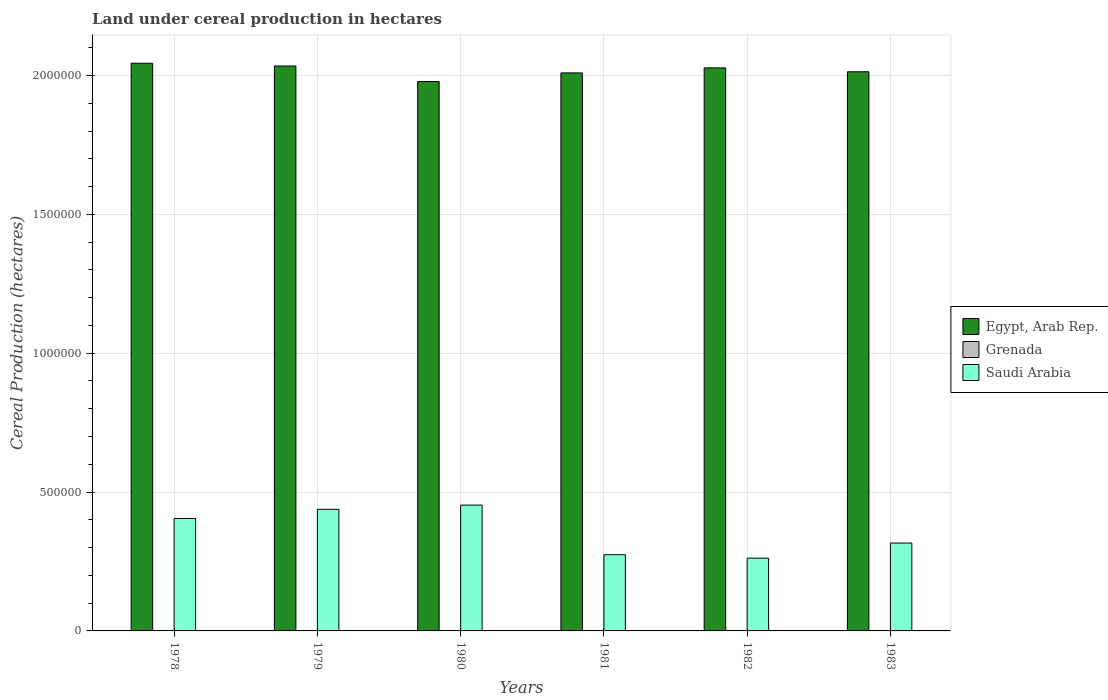How many different coloured bars are there?
Your answer should be very brief. 3. How many groups of bars are there?
Offer a very short reply. 6. Are the number of bars per tick equal to the number of legend labels?
Provide a succinct answer. Yes. Are the number of bars on each tick of the X-axis equal?
Make the answer very short. Yes. How many bars are there on the 1st tick from the right?
Your answer should be very brief. 3. What is the label of the 3rd group of bars from the left?
Offer a terse response. 1980. In how many cases, is the number of bars for a given year not equal to the number of legend labels?
Make the answer very short. 0. What is the land under cereal production in Grenada in 1981?
Your answer should be compact. 450. Across all years, what is the maximum land under cereal production in Saudi Arabia?
Your answer should be very brief. 4.53e+05. Across all years, what is the minimum land under cereal production in Egypt, Arab Rep.?
Offer a terse response. 1.98e+06. In which year was the land under cereal production in Egypt, Arab Rep. maximum?
Offer a very short reply. 1978. What is the total land under cereal production in Egypt, Arab Rep. in the graph?
Offer a terse response. 1.21e+07. What is the difference between the land under cereal production in Saudi Arabia in 1978 and that in 1980?
Ensure brevity in your answer.  -4.81e+04. What is the difference between the land under cereal production in Egypt, Arab Rep. in 1983 and the land under cereal production in Grenada in 1979?
Make the answer very short. 2.01e+06. What is the average land under cereal production in Egypt, Arab Rep. per year?
Give a very brief answer. 2.02e+06. In the year 1983, what is the difference between the land under cereal production in Grenada and land under cereal production in Saudi Arabia?
Provide a succinct answer. -3.16e+05. What is the ratio of the land under cereal production in Saudi Arabia in 1981 to that in 1983?
Provide a short and direct response. 0.87. What is the difference between the highest and the second highest land under cereal production in Grenada?
Offer a terse response. 124. What is the difference between the highest and the lowest land under cereal production in Grenada?
Offer a very short reply. 316. Is the sum of the land under cereal production in Grenada in 1979 and 1981 greater than the maximum land under cereal production in Saudi Arabia across all years?
Keep it short and to the point. No. What does the 2nd bar from the left in 1979 represents?
Ensure brevity in your answer.  Grenada. What does the 2nd bar from the right in 1981 represents?
Give a very brief answer. Grenada. Is it the case that in every year, the sum of the land under cereal production in Saudi Arabia and land under cereal production in Egypt, Arab Rep. is greater than the land under cereal production in Grenada?
Keep it short and to the point. Yes. How many bars are there?
Offer a very short reply. 18. Are all the bars in the graph horizontal?
Provide a succinct answer. No. Where does the legend appear in the graph?
Your response must be concise. Center right. How many legend labels are there?
Provide a short and direct response. 3. What is the title of the graph?
Offer a terse response. Land under cereal production in hectares. What is the label or title of the X-axis?
Your answer should be very brief. Years. What is the label or title of the Y-axis?
Ensure brevity in your answer.  Cereal Production (hectares). What is the Cereal Production (hectares) in Egypt, Arab Rep. in 1978?
Provide a succinct answer. 2.04e+06. What is the Cereal Production (hectares) of Grenada in 1978?
Offer a terse response. 730. What is the Cereal Production (hectares) in Saudi Arabia in 1978?
Keep it short and to the point. 4.05e+05. What is the Cereal Production (hectares) of Egypt, Arab Rep. in 1979?
Give a very brief answer. 2.03e+06. What is the Cereal Production (hectares) of Grenada in 1979?
Your response must be concise. 606. What is the Cereal Production (hectares) of Saudi Arabia in 1979?
Ensure brevity in your answer.  4.38e+05. What is the Cereal Production (hectares) in Egypt, Arab Rep. in 1980?
Give a very brief answer. 1.98e+06. What is the Cereal Production (hectares) in Saudi Arabia in 1980?
Make the answer very short. 4.53e+05. What is the Cereal Production (hectares) in Egypt, Arab Rep. in 1981?
Offer a very short reply. 2.01e+06. What is the Cereal Production (hectares) in Grenada in 1981?
Give a very brief answer. 450. What is the Cereal Production (hectares) of Saudi Arabia in 1981?
Make the answer very short. 2.74e+05. What is the Cereal Production (hectares) in Egypt, Arab Rep. in 1982?
Offer a very short reply. 2.03e+06. What is the Cereal Production (hectares) in Grenada in 1982?
Offer a terse response. 470. What is the Cereal Production (hectares) of Saudi Arabia in 1982?
Ensure brevity in your answer.  2.62e+05. What is the Cereal Production (hectares) of Egypt, Arab Rep. in 1983?
Provide a succinct answer. 2.01e+06. What is the Cereal Production (hectares) of Grenada in 1983?
Keep it short and to the point. 414. What is the Cereal Production (hectares) in Saudi Arabia in 1983?
Your response must be concise. 3.16e+05. Across all years, what is the maximum Cereal Production (hectares) of Egypt, Arab Rep.?
Your answer should be compact. 2.04e+06. Across all years, what is the maximum Cereal Production (hectares) of Grenada?
Offer a very short reply. 730. Across all years, what is the maximum Cereal Production (hectares) of Saudi Arabia?
Provide a succinct answer. 4.53e+05. Across all years, what is the minimum Cereal Production (hectares) in Egypt, Arab Rep.?
Ensure brevity in your answer.  1.98e+06. Across all years, what is the minimum Cereal Production (hectares) of Grenada?
Offer a terse response. 414. Across all years, what is the minimum Cereal Production (hectares) of Saudi Arabia?
Give a very brief answer. 2.62e+05. What is the total Cereal Production (hectares) of Egypt, Arab Rep. in the graph?
Keep it short and to the point. 1.21e+07. What is the total Cereal Production (hectares) in Grenada in the graph?
Offer a very short reply. 3170. What is the total Cereal Production (hectares) of Saudi Arabia in the graph?
Your answer should be compact. 2.15e+06. What is the difference between the Cereal Production (hectares) of Egypt, Arab Rep. in 1978 and that in 1979?
Your answer should be very brief. 9896. What is the difference between the Cereal Production (hectares) in Grenada in 1978 and that in 1979?
Give a very brief answer. 124. What is the difference between the Cereal Production (hectares) in Saudi Arabia in 1978 and that in 1979?
Provide a short and direct response. -3.30e+04. What is the difference between the Cereal Production (hectares) of Egypt, Arab Rep. in 1978 and that in 1980?
Ensure brevity in your answer.  6.58e+04. What is the difference between the Cereal Production (hectares) in Grenada in 1978 and that in 1980?
Ensure brevity in your answer.  230. What is the difference between the Cereal Production (hectares) in Saudi Arabia in 1978 and that in 1980?
Provide a succinct answer. -4.81e+04. What is the difference between the Cereal Production (hectares) in Egypt, Arab Rep. in 1978 and that in 1981?
Provide a succinct answer. 3.47e+04. What is the difference between the Cereal Production (hectares) of Grenada in 1978 and that in 1981?
Give a very brief answer. 280. What is the difference between the Cereal Production (hectares) of Saudi Arabia in 1978 and that in 1981?
Provide a short and direct response. 1.31e+05. What is the difference between the Cereal Production (hectares) in Egypt, Arab Rep. in 1978 and that in 1982?
Your response must be concise. 1.67e+04. What is the difference between the Cereal Production (hectares) of Grenada in 1978 and that in 1982?
Offer a terse response. 260. What is the difference between the Cereal Production (hectares) of Saudi Arabia in 1978 and that in 1982?
Keep it short and to the point. 1.43e+05. What is the difference between the Cereal Production (hectares) in Egypt, Arab Rep. in 1978 and that in 1983?
Offer a very short reply. 3.06e+04. What is the difference between the Cereal Production (hectares) of Grenada in 1978 and that in 1983?
Your response must be concise. 316. What is the difference between the Cereal Production (hectares) in Saudi Arabia in 1978 and that in 1983?
Your response must be concise. 8.85e+04. What is the difference between the Cereal Production (hectares) in Egypt, Arab Rep. in 1979 and that in 1980?
Your answer should be compact. 5.59e+04. What is the difference between the Cereal Production (hectares) in Grenada in 1979 and that in 1980?
Offer a very short reply. 106. What is the difference between the Cereal Production (hectares) of Saudi Arabia in 1979 and that in 1980?
Your answer should be very brief. -1.52e+04. What is the difference between the Cereal Production (hectares) in Egypt, Arab Rep. in 1979 and that in 1981?
Keep it short and to the point. 2.48e+04. What is the difference between the Cereal Production (hectares) in Grenada in 1979 and that in 1981?
Offer a very short reply. 156. What is the difference between the Cereal Production (hectares) of Saudi Arabia in 1979 and that in 1981?
Give a very brief answer. 1.64e+05. What is the difference between the Cereal Production (hectares) in Egypt, Arab Rep. in 1979 and that in 1982?
Provide a succinct answer. 6838. What is the difference between the Cereal Production (hectares) in Grenada in 1979 and that in 1982?
Provide a short and direct response. 136. What is the difference between the Cereal Production (hectares) of Saudi Arabia in 1979 and that in 1982?
Offer a very short reply. 1.76e+05. What is the difference between the Cereal Production (hectares) in Egypt, Arab Rep. in 1979 and that in 1983?
Your answer should be very brief. 2.07e+04. What is the difference between the Cereal Production (hectares) in Grenada in 1979 and that in 1983?
Make the answer very short. 192. What is the difference between the Cereal Production (hectares) of Saudi Arabia in 1979 and that in 1983?
Your answer should be compact. 1.21e+05. What is the difference between the Cereal Production (hectares) in Egypt, Arab Rep. in 1980 and that in 1981?
Your answer should be very brief. -3.10e+04. What is the difference between the Cereal Production (hectares) of Saudi Arabia in 1980 and that in 1981?
Your answer should be compact. 1.79e+05. What is the difference between the Cereal Production (hectares) of Egypt, Arab Rep. in 1980 and that in 1982?
Provide a short and direct response. -4.91e+04. What is the difference between the Cereal Production (hectares) in Saudi Arabia in 1980 and that in 1982?
Your response must be concise. 1.91e+05. What is the difference between the Cereal Production (hectares) of Egypt, Arab Rep. in 1980 and that in 1983?
Ensure brevity in your answer.  -3.52e+04. What is the difference between the Cereal Production (hectares) in Grenada in 1980 and that in 1983?
Provide a short and direct response. 86. What is the difference between the Cereal Production (hectares) of Saudi Arabia in 1980 and that in 1983?
Your answer should be compact. 1.37e+05. What is the difference between the Cereal Production (hectares) of Egypt, Arab Rep. in 1981 and that in 1982?
Provide a short and direct response. -1.80e+04. What is the difference between the Cereal Production (hectares) in Saudi Arabia in 1981 and that in 1982?
Offer a very short reply. 1.24e+04. What is the difference between the Cereal Production (hectares) of Egypt, Arab Rep. in 1981 and that in 1983?
Give a very brief answer. -4115. What is the difference between the Cereal Production (hectares) of Saudi Arabia in 1981 and that in 1983?
Provide a short and direct response. -4.21e+04. What is the difference between the Cereal Production (hectares) in Egypt, Arab Rep. in 1982 and that in 1983?
Provide a short and direct response. 1.39e+04. What is the difference between the Cereal Production (hectares) of Saudi Arabia in 1982 and that in 1983?
Keep it short and to the point. -5.45e+04. What is the difference between the Cereal Production (hectares) of Egypt, Arab Rep. in 1978 and the Cereal Production (hectares) of Grenada in 1979?
Your answer should be compact. 2.04e+06. What is the difference between the Cereal Production (hectares) of Egypt, Arab Rep. in 1978 and the Cereal Production (hectares) of Saudi Arabia in 1979?
Offer a terse response. 1.61e+06. What is the difference between the Cereal Production (hectares) of Grenada in 1978 and the Cereal Production (hectares) of Saudi Arabia in 1979?
Your response must be concise. -4.37e+05. What is the difference between the Cereal Production (hectares) of Egypt, Arab Rep. in 1978 and the Cereal Production (hectares) of Grenada in 1980?
Your response must be concise. 2.04e+06. What is the difference between the Cereal Production (hectares) of Egypt, Arab Rep. in 1978 and the Cereal Production (hectares) of Saudi Arabia in 1980?
Offer a terse response. 1.59e+06. What is the difference between the Cereal Production (hectares) in Grenada in 1978 and the Cereal Production (hectares) in Saudi Arabia in 1980?
Offer a terse response. -4.52e+05. What is the difference between the Cereal Production (hectares) in Egypt, Arab Rep. in 1978 and the Cereal Production (hectares) in Grenada in 1981?
Ensure brevity in your answer.  2.04e+06. What is the difference between the Cereal Production (hectares) in Egypt, Arab Rep. in 1978 and the Cereal Production (hectares) in Saudi Arabia in 1981?
Give a very brief answer. 1.77e+06. What is the difference between the Cereal Production (hectares) in Grenada in 1978 and the Cereal Production (hectares) in Saudi Arabia in 1981?
Ensure brevity in your answer.  -2.74e+05. What is the difference between the Cereal Production (hectares) in Egypt, Arab Rep. in 1978 and the Cereal Production (hectares) in Grenada in 1982?
Make the answer very short. 2.04e+06. What is the difference between the Cereal Production (hectares) in Egypt, Arab Rep. in 1978 and the Cereal Production (hectares) in Saudi Arabia in 1982?
Your response must be concise. 1.78e+06. What is the difference between the Cereal Production (hectares) in Grenada in 1978 and the Cereal Production (hectares) in Saudi Arabia in 1982?
Provide a succinct answer. -2.61e+05. What is the difference between the Cereal Production (hectares) in Egypt, Arab Rep. in 1978 and the Cereal Production (hectares) in Grenada in 1983?
Offer a very short reply. 2.04e+06. What is the difference between the Cereal Production (hectares) in Egypt, Arab Rep. in 1978 and the Cereal Production (hectares) in Saudi Arabia in 1983?
Keep it short and to the point. 1.73e+06. What is the difference between the Cereal Production (hectares) in Grenada in 1978 and the Cereal Production (hectares) in Saudi Arabia in 1983?
Your response must be concise. -3.16e+05. What is the difference between the Cereal Production (hectares) of Egypt, Arab Rep. in 1979 and the Cereal Production (hectares) of Grenada in 1980?
Make the answer very short. 2.03e+06. What is the difference between the Cereal Production (hectares) in Egypt, Arab Rep. in 1979 and the Cereal Production (hectares) in Saudi Arabia in 1980?
Provide a succinct answer. 1.58e+06. What is the difference between the Cereal Production (hectares) of Grenada in 1979 and the Cereal Production (hectares) of Saudi Arabia in 1980?
Offer a terse response. -4.52e+05. What is the difference between the Cereal Production (hectares) in Egypt, Arab Rep. in 1979 and the Cereal Production (hectares) in Grenada in 1981?
Provide a succinct answer. 2.03e+06. What is the difference between the Cereal Production (hectares) in Egypt, Arab Rep. in 1979 and the Cereal Production (hectares) in Saudi Arabia in 1981?
Ensure brevity in your answer.  1.76e+06. What is the difference between the Cereal Production (hectares) in Grenada in 1979 and the Cereal Production (hectares) in Saudi Arabia in 1981?
Provide a short and direct response. -2.74e+05. What is the difference between the Cereal Production (hectares) of Egypt, Arab Rep. in 1979 and the Cereal Production (hectares) of Grenada in 1982?
Offer a terse response. 2.03e+06. What is the difference between the Cereal Production (hectares) of Egypt, Arab Rep. in 1979 and the Cereal Production (hectares) of Saudi Arabia in 1982?
Your response must be concise. 1.77e+06. What is the difference between the Cereal Production (hectares) in Grenada in 1979 and the Cereal Production (hectares) in Saudi Arabia in 1982?
Your response must be concise. -2.61e+05. What is the difference between the Cereal Production (hectares) in Egypt, Arab Rep. in 1979 and the Cereal Production (hectares) in Grenada in 1983?
Ensure brevity in your answer.  2.03e+06. What is the difference between the Cereal Production (hectares) in Egypt, Arab Rep. in 1979 and the Cereal Production (hectares) in Saudi Arabia in 1983?
Provide a succinct answer. 1.72e+06. What is the difference between the Cereal Production (hectares) of Grenada in 1979 and the Cereal Production (hectares) of Saudi Arabia in 1983?
Provide a succinct answer. -3.16e+05. What is the difference between the Cereal Production (hectares) of Egypt, Arab Rep. in 1980 and the Cereal Production (hectares) of Grenada in 1981?
Provide a short and direct response. 1.98e+06. What is the difference between the Cereal Production (hectares) of Egypt, Arab Rep. in 1980 and the Cereal Production (hectares) of Saudi Arabia in 1981?
Make the answer very short. 1.70e+06. What is the difference between the Cereal Production (hectares) of Grenada in 1980 and the Cereal Production (hectares) of Saudi Arabia in 1981?
Offer a very short reply. -2.74e+05. What is the difference between the Cereal Production (hectares) in Egypt, Arab Rep. in 1980 and the Cereal Production (hectares) in Grenada in 1982?
Your response must be concise. 1.98e+06. What is the difference between the Cereal Production (hectares) in Egypt, Arab Rep. in 1980 and the Cereal Production (hectares) in Saudi Arabia in 1982?
Provide a short and direct response. 1.72e+06. What is the difference between the Cereal Production (hectares) of Grenada in 1980 and the Cereal Production (hectares) of Saudi Arabia in 1982?
Keep it short and to the point. -2.61e+05. What is the difference between the Cereal Production (hectares) in Egypt, Arab Rep. in 1980 and the Cereal Production (hectares) in Grenada in 1983?
Your answer should be very brief. 1.98e+06. What is the difference between the Cereal Production (hectares) in Egypt, Arab Rep. in 1980 and the Cereal Production (hectares) in Saudi Arabia in 1983?
Your answer should be very brief. 1.66e+06. What is the difference between the Cereal Production (hectares) in Grenada in 1980 and the Cereal Production (hectares) in Saudi Arabia in 1983?
Ensure brevity in your answer.  -3.16e+05. What is the difference between the Cereal Production (hectares) of Egypt, Arab Rep. in 1981 and the Cereal Production (hectares) of Grenada in 1982?
Your answer should be very brief. 2.01e+06. What is the difference between the Cereal Production (hectares) of Egypt, Arab Rep. in 1981 and the Cereal Production (hectares) of Saudi Arabia in 1982?
Ensure brevity in your answer.  1.75e+06. What is the difference between the Cereal Production (hectares) in Grenada in 1981 and the Cereal Production (hectares) in Saudi Arabia in 1982?
Your response must be concise. -2.61e+05. What is the difference between the Cereal Production (hectares) in Egypt, Arab Rep. in 1981 and the Cereal Production (hectares) in Grenada in 1983?
Keep it short and to the point. 2.01e+06. What is the difference between the Cereal Production (hectares) of Egypt, Arab Rep. in 1981 and the Cereal Production (hectares) of Saudi Arabia in 1983?
Your answer should be compact. 1.69e+06. What is the difference between the Cereal Production (hectares) in Grenada in 1981 and the Cereal Production (hectares) in Saudi Arabia in 1983?
Your answer should be compact. -3.16e+05. What is the difference between the Cereal Production (hectares) of Egypt, Arab Rep. in 1982 and the Cereal Production (hectares) of Grenada in 1983?
Provide a succinct answer. 2.03e+06. What is the difference between the Cereal Production (hectares) of Egypt, Arab Rep. in 1982 and the Cereal Production (hectares) of Saudi Arabia in 1983?
Your answer should be compact. 1.71e+06. What is the difference between the Cereal Production (hectares) of Grenada in 1982 and the Cereal Production (hectares) of Saudi Arabia in 1983?
Offer a very short reply. -3.16e+05. What is the average Cereal Production (hectares) in Egypt, Arab Rep. per year?
Give a very brief answer. 2.02e+06. What is the average Cereal Production (hectares) in Grenada per year?
Your answer should be very brief. 528.33. What is the average Cereal Production (hectares) of Saudi Arabia per year?
Offer a terse response. 3.58e+05. In the year 1978, what is the difference between the Cereal Production (hectares) of Egypt, Arab Rep. and Cereal Production (hectares) of Grenada?
Your answer should be compact. 2.04e+06. In the year 1978, what is the difference between the Cereal Production (hectares) of Egypt, Arab Rep. and Cereal Production (hectares) of Saudi Arabia?
Your answer should be very brief. 1.64e+06. In the year 1978, what is the difference between the Cereal Production (hectares) in Grenada and Cereal Production (hectares) in Saudi Arabia?
Provide a succinct answer. -4.04e+05. In the year 1979, what is the difference between the Cereal Production (hectares) in Egypt, Arab Rep. and Cereal Production (hectares) in Grenada?
Make the answer very short. 2.03e+06. In the year 1979, what is the difference between the Cereal Production (hectares) of Egypt, Arab Rep. and Cereal Production (hectares) of Saudi Arabia?
Offer a terse response. 1.60e+06. In the year 1979, what is the difference between the Cereal Production (hectares) in Grenada and Cereal Production (hectares) in Saudi Arabia?
Give a very brief answer. -4.37e+05. In the year 1980, what is the difference between the Cereal Production (hectares) in Egypt, Arab Rep. and Cereal Production (hectares) in Grenada?
Your answer should be very brief. 1.98e+06. In the year 1980, what is the difference between the Cereal Production (hectares) in Egypt, Arab Rep. and Cereal Production (hectares) in Saudi Arabia?
Make the answer very short. 1.53e+06. In the year 1980, what is the difference between the Cereal Production (hectares) of Grenada and Cereal Production (hectares) of Saudi Arabia?
Keep it short and to the point. -4.53e+05. In the year 1981, what is the difference between the Cereal Production (hectares) in Egypt, Arab Rep. and Cereal Production (hectares) in Grenada?
Your answer should be very brief. 2.01e+06. In the year 1981, what is the difference between the Cereal Production (hectares) in Egypt, Arab Rep. and Cereal Production (hectares) in Saudi Arabia?
Provide a succinct answer. 1.73e+06. In the year 1981, what is the difference between the Cereal Production (hectares) in Grenada and Cereal Production (hectares) in Saudi Arabia?
Provide a short and direct response. -2.74e+05. In the year 1982, what is the difference between the Cereal Production (hectares) in Egypt, Arab Rep. and Cereal Production (hectares) in Grenada?
Offer a very short reply. 2.03e+06. In the year 1982, what is the difference between the Cereal Production (hectares) in Egypt, Arab Rep. and Cereal Production (hectares) in Saudi Arabia?
Keep it short and to the point. 1.77e+06. In the year 1982, what is the difference between the Cereal Production (hectares) in Grenada and Cereal Production (hectares) in Saudi Arabia?
Your answer should be very brief. -2.61e+05. In the year 1983, what is the difference between the Cereal Production (hectares) of Egypt, Arab Rep. and Cereal Production (hectares) of Grenada?
Your answer should be very brief. 2.01e+06. In the year 1983, what is the difference between the Cereal Production (hectares) in Egypt, Arab Rep. and Cereal Production (hectares) in Saudi Arabia?
Offer a very short reply. 1.70e+06. In the year 1983, what is the difference between the Cereal Production (hectares) in Grenada and Cereal Production (hectares) in Saudi Arabia?
Your answer should be compact. -3.16e+05. What is the ratio of the Cereal Production (hectares) of Egypt, Arab Rep. in 1978 to that in 1979?
Keep it short and to the point. 1. What is the ratio of the Cereal Production (hectares) in Grenada in 1978 to that in 1979?
Provide a short and direct response. 1.2. What is the ratio of the Cereal Production (hectares) of Saudi Arabia in 1978 to that in 1979?
Your answer should be compact. 0.92. What is the ratio of the Cereal Production (hectares) of Egypt, Arab Rep. in 1978 to that in 1980?
Make the answer very short. 1.03. What is the ratio of the Cereal Production (hectares) in Grenada in 1978 to that in 1980?
Make the answer very short. 1.46. What is the ratio of the Cereal Production (hectares) in Saudi Arabia in 1978 to that in 1980?
Your response must be concise. 0.89. What is the ratio of the Cereal Production (hectares) of Egypt, Arab Rep. in 1978 to that in 1981?
Offer a very short reply. 1.02. What is the ratio of the Cereal Production (hectares) of Grenada in 1978 to that in 1981?
Offer a terse response. 1.62. What is the ratio of the Cereal Production (hectares) in Saudi Arabia in 1978 to that in 1981?
Your answer should be compact. 1.48. What is the ratio of the Cereal Production (hectares) in Egypt, Arab Rep. in 1978 to that in 1982?
Offer a very short reply. 1.01. What is the ratio of the Cereal Production (hectares) in Grenada in 1978 to that in 1982?
Your response must be concise. 1.55. What is the ratio of the Cereal Production (hectares) in Saudi Arabia in 1978 to that in 1982?
Offer a very short reply. 1.55. What is the ratio of the Cereal Production (hectares) of Egypt, Arab Rep. in 1978 to that in 1983?
Offer a very short reply. 1.02. What is the ratio of the Cereal Production (hectares) of Grenada in 1978 to that in 1983?
Make the answer very short. 1.76. What is the ratio of the Cereal Production (hectares) of Saudi Arabia in 1978 to that in 1983?
Keep it short and to the point. 1.28. What is the ratio of the Cereal Production (hectares) in Egypt, Arab Rep. in 1979 to that in 1980?
Make the answer very short. 1.03. What is the ratio of the Cereal Production (hectares) in Grenada in 1979 to that in 1980?
Make the answer very short. 1.21. What is the ratio of the Cereal Production (hectares) of Saudi Arabia in 1979 to that in 1980?
Your answer should be very brief. 0.97. What is the ratio of the Cereal Production (hectares) in Egypt, Arab Rep. in 1979 to that in 1981?
Make the answer very short. 1.01. What is the ratio of the Cereal Production (hectares) of Grenada in 1979 to that in 1981?
Your answer should be compact. 1.35. What is the ratio of the Cereal Production (hectares) of Saudi Arabia in 1979 to that in 1981?
Your answer should be compact. 1.6. What is the ratio of the Cereal Production (hectares) in Egypt, Arab Rep. in 1979 to that in 1982?
Ensure brevity in your answer.  1. What is the ratio of the Cereal Production (hectares) in Grenada in 1979 to that in 1982?
Provide a succinct answer. 1.29. What is the ratio of the Cereal Production (hectares) in Saudi Arabia in 1979 to that in 1982?
Offer a very short reply. 1.67. What is the ratio of the Cereal Production (hectares) in Egypt, Arab Rep. in 1979 to that in 1983?
Your answer should be very brief. 1.01. What is the ratio of the Cereal Production (hectares) of Grenada in 1979 to that in 1983?
Your answer should be very brief. 1.46. What is the ratio of the Cereal Production (hectares) in Saudi Arabia in 1979 to that in 1983?
Provide a short and direct response. 1.38. What is the ratio of the Cereal Production (hectares) of Egypt, Arab Rep. in 1980 to that in 1981?
Your response must be concise. 0.98. What is the ratio of the Cereal Production (hectares) in Saudi Arabia in 1980 to that in 1981?
Offer a very short reply. 1.65. What is the ratio of the Cereal Production (hectares) of Egypt, Arab Rep. in 1980 to that in 1982?
Offer a terse response. 0.98. What is the ratio of the Cereal Production (hectares) in Grenada in 1980 to that in 1982?
Provide a succinct answer. 1.06. What is the ratio of the Cereal Production (hectares) of Saudi Arabia in 1980 to that in 1982?
Your answer should be compact. 1.73. What is the ratio of the Cereal Production (hectares) in Egypt, Arab Rep. in 1980 to that in 1983?
Your answer should be very brief. 0.98. What is the ratio of the Cereal Production (hectares) in Grenada in 1980 to that in 1983?
Offer a terse response. 1.21. What is the ratio of the Cereal Production (hectares) of Saudi Arabia in 1980 to that in 1983?
Your response must be concise. 1.43. What is the ratio of the Cereal Production (hectares) in Grenada in 1981 to that in 1982?
Make the answer very short. 0.96. What is the ratio of the Cereal Production (hectares) of Saudi Arabia in 1981 to that in 1982?
Ensure brevity in your answer.  1.05. What is the ratio of the Cereal Production (hectares) in Grenada in 1981 to that in 1983?
Provide a short and direct response. 1.09. What is the ratio of the Cereal Production (hectares) in Saudi Arabia in 1981 to that in 1983?
Your answer should be compact. 0.87. What is the ratio of the Cereal Production (hectares) in Egypt, Arab Rep. in 1982 to that in 1983?
Keep it short and to the point. 1.01. What is the ratio of the Cereal Production (hectares) in Grenada in 1982 to that in 1983?
Give a very brief answer. 1.14. What is the ratio of the Cereal Production (hectares) of Saudi Arabia in 1982 to that in 1983?
Provide a short and direct response. 0.83. What is the difference between the highest and the second highest Cereal Production (hectares) of Egypt, Arab Rep.?
Keep it short and to the point. 9896. What is the difference between the highest and the second highest Cereal Production (hectares) in Grenada?
Give a very brief answer. 124. What is the difference between the highest and the second highest Cereal Production (hectares) of Saudi Arabia?
Offer a very short reply. 1.52e+04. What is the difference between the highest and the lowest Cereal Production (hectares) of Egypt, Arab Rep.?
Make the answer very short. 6.58e+04. What is the difference between the highest and the lowest Cereal Production (hectares) in Grenada?
Your answer should be very brief. 316. What is the difference between the highest and the lowest Cereal Production (hectares) of Saudi Arabia?
Your answer should be very brief. 1.91e+05. 